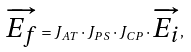<formula> <loc_0><loc_0><loc_500><loc_500>\overrightarrow { E _ { f } } = J _ { A T } \cdot J _ { P S } \cdot J _ { C P } \cdot \overrightarrow { E _ { i } } ,</formula> 